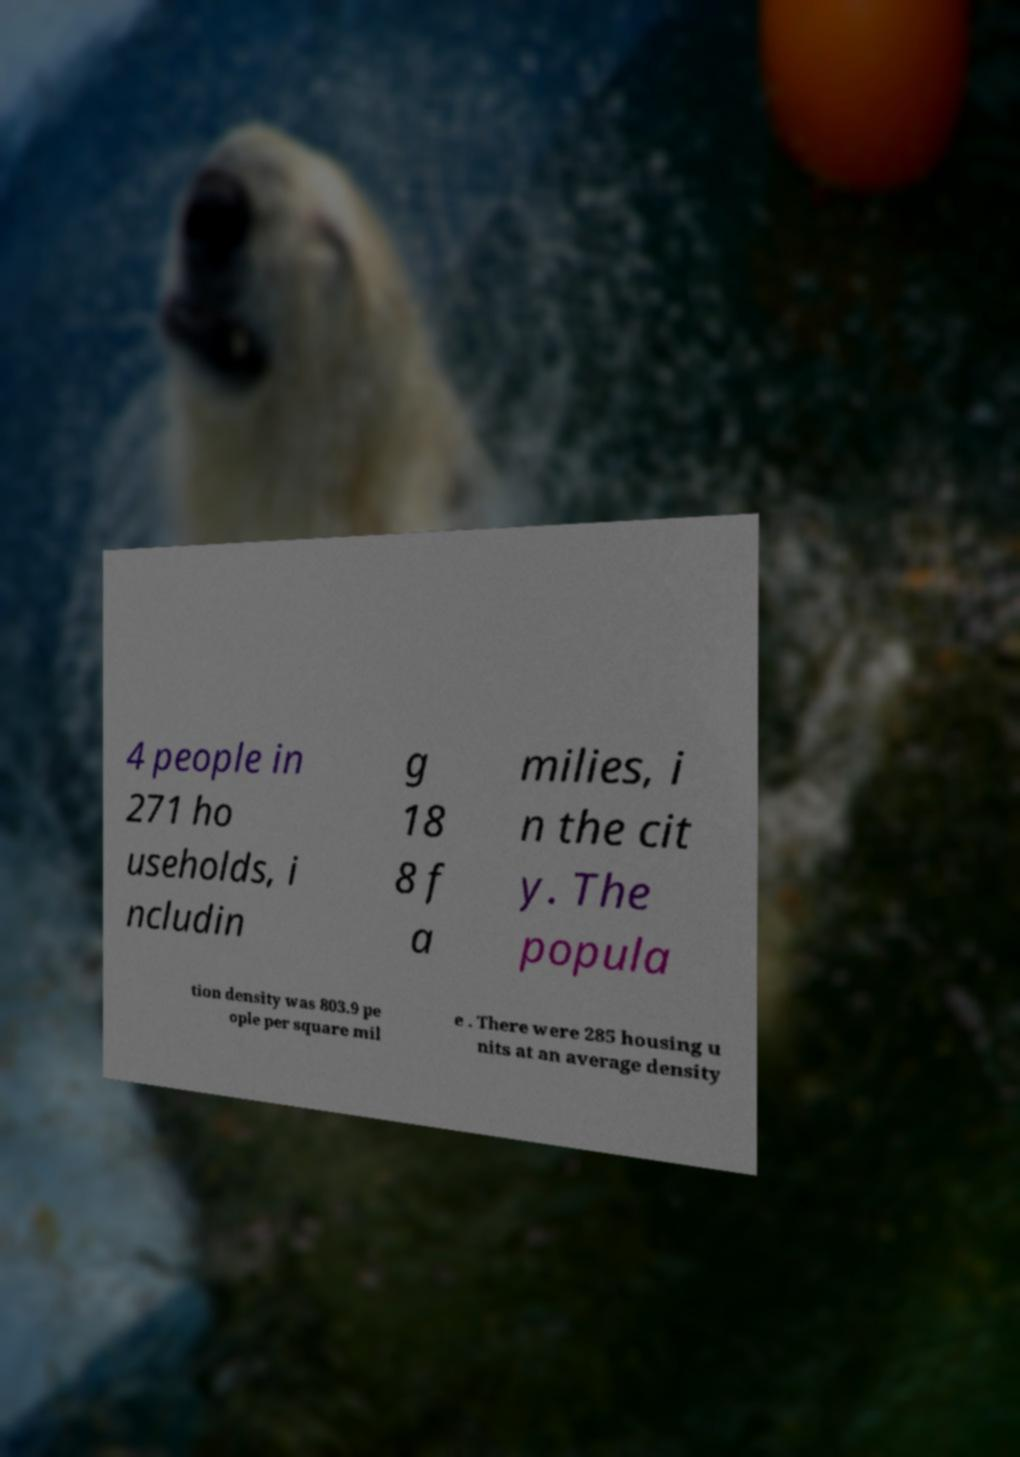What messages or text are displayed in this image? I need them in a readable, typed format. 4 people in 271 ho useholds, i ncludin g 18 8 f a milies, i n the cit y. The popula tion density was 803.9 pe ople per square mil e . There were 285 housing u nits at an average density 